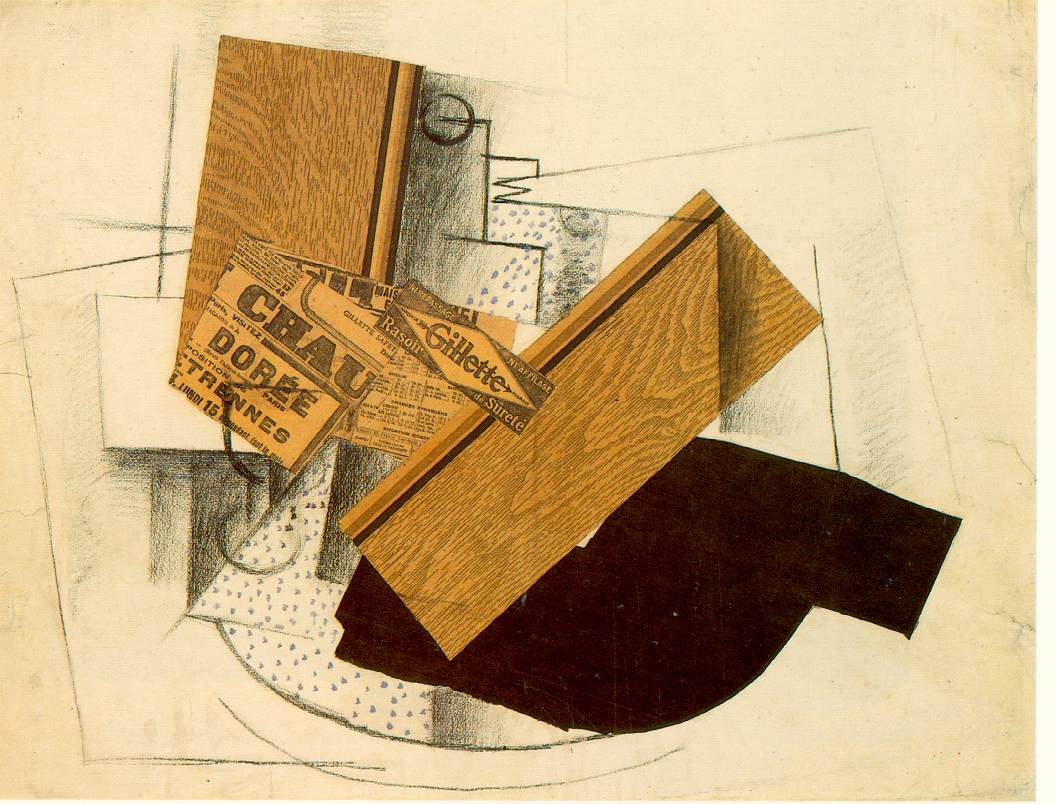What does the presence of the newspaper in this artwork suggest about the period it was created in? The inclusion of a newspaper fragment in this cubist artwork likely points to the artist's intent to merge contemporary events with abstract forms, a practice common in early 20th-century modern art. By embedding actual, readable text within the abstract geometry, the artist may be commenting on the pervasive influence of media and communication on society's perception of reality. It suggests a critical viewpoint or a reflective inquiry into the role of media in shaping public consciousness during that era. Can you describe any specific themes that might be derived from the abstract forms seen in the artwork? The abstract forms in this cubist painting, such as the disjointed geometric shapes and the overlapping planes, can be interpreted as exploring themes of fragmentation and reconstruction. This could symbolize the tumultuous changes in society and technology occurring during the early 20th century, reflecting on how these disruptions affect human perception and understanding. Each shape might represent different facets of society or personal identity, dissected and rearranged to challenge the viewer's traditional viewpoints and encourage a more dynamic interpretation of reality. 